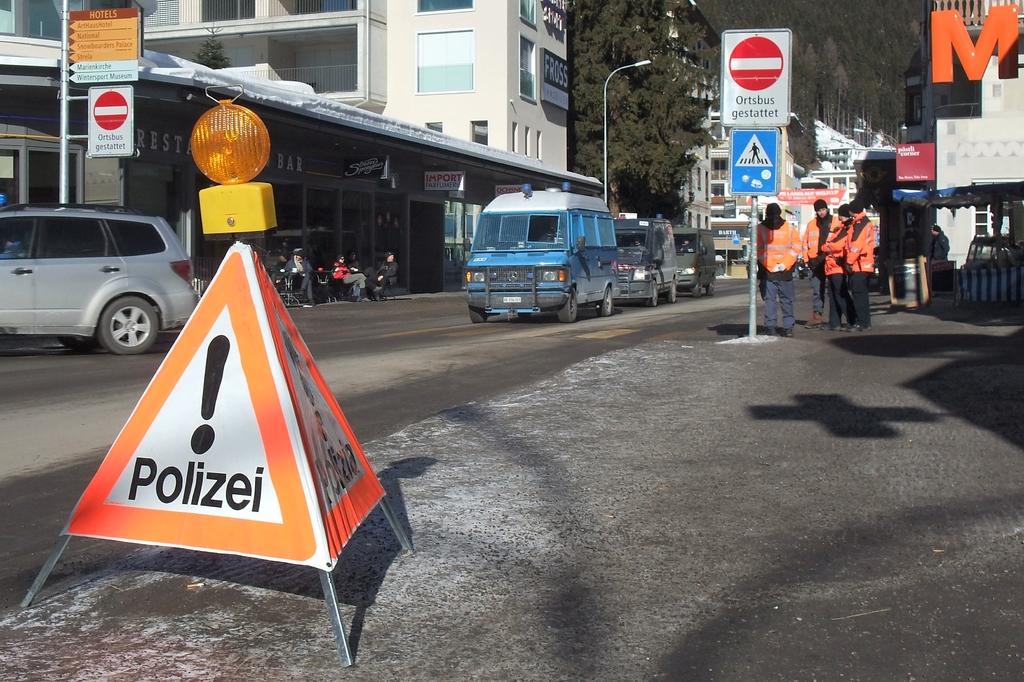What does the sign warn about?
Provide a short and direct response. Polizei. 